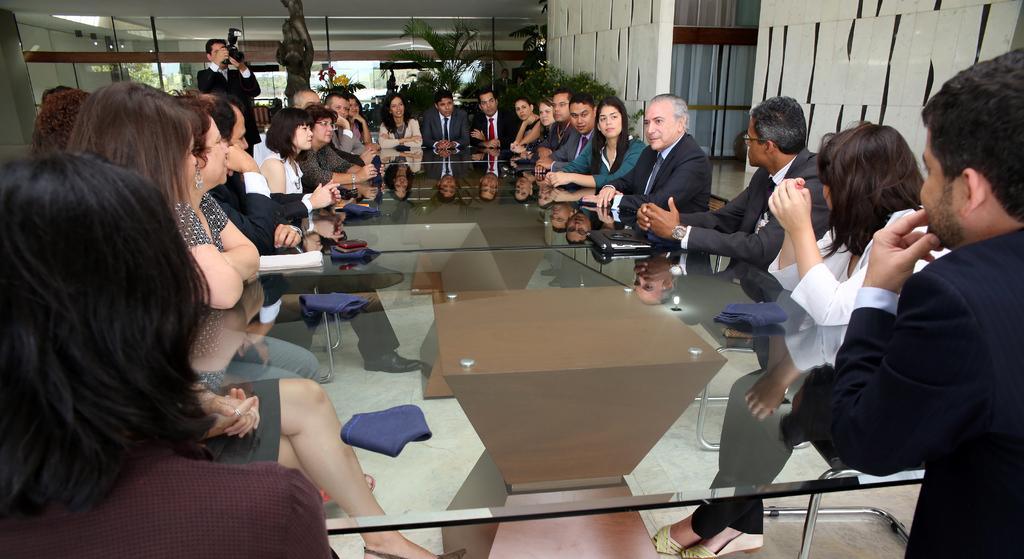Could you give a brief overview of what you see in this image? Most of the persons are sitting on chair, on this table there is a cloth, laptop and things. Far there are plants. This man is standing and holding a camera. On this wall there are posters. 